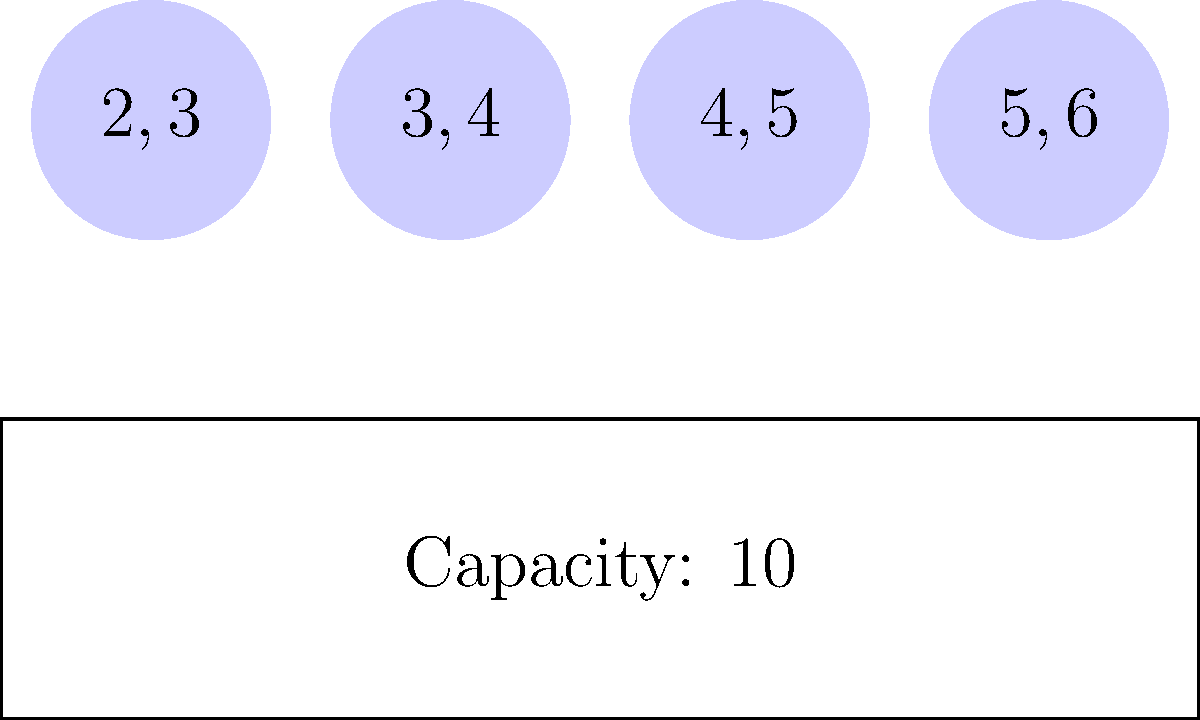In Dungeons of Dredmor, you've encountered a challenging inventory management situation. Given the knapsack problem visualization above, where each circle represents an item with weight and value (weight,value), and the rectangle represents your inventory capacity, what is the maximum total value you can carry without exceeding the weight limit? Assume you can't take partial items. Let's approach this step-by-step using the 0-1 knapsack algorithm:

1) First, let's identify our items:
   Item 1: weight = 2, value = 3
   Item 2: weight = 3, value = 4
   Item 3: weight = 4, value = 5
   Item 4: weight = 5, value = 6

2) Our capacity (W) is 10.

3) We'll create a table DP[i][w] where i is the number of items considered and w is the current weight.

4) Initialize the table:
   DP[0][w] = 0 for all w
   DP[i][0] = 0 for all i

5) Fill the table using the formula:
   If weight of item i ≤ w:
      DP[i][w] = max(DP[i-1][w], DP[i-1][w-weight[i]] + value[i])
   Else:
      DP[i][w] = DP[i-1][w]

6) After filling:

   w  0  1  2  3  4  5  6  7  8  9 10
i
0  0  0  0  0  0  0  0  0  0  0  0
1  0  0  3  3  3  3  3  3  3  3  3
2  0  0  3  4  4  7  7  7  7  7  7
3  0  0  3  4  5  7  8  9  9 12 12
4  0  0  3  4  5  7  8  9  9 12 13

7) The maximum value is in DP[4][10] = 13.

This means you can carry items with a total value of 13 without exceeding the weight limit of 10.
Answer: 13 